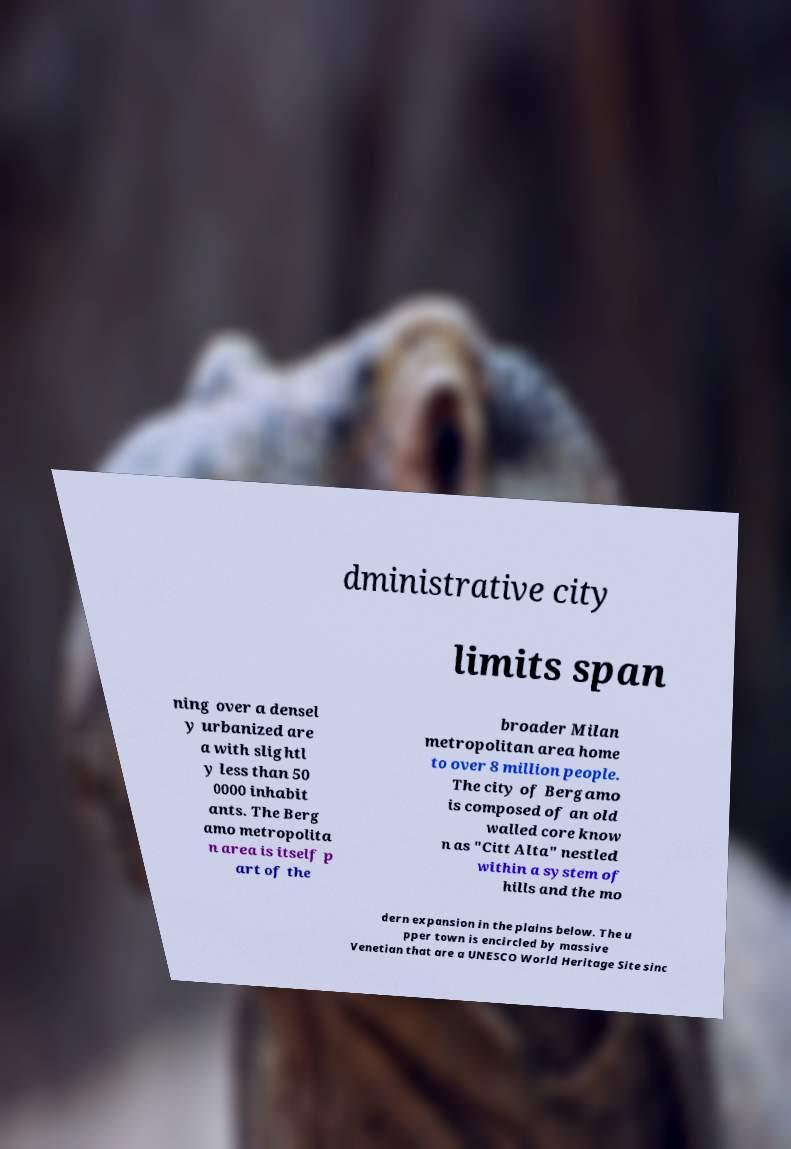I need the written content from this picture converted into text. Can you do that? dministrative city limits span ning over a densel y urbanized are a with slightl y less than 50 0000 inhabit ants. The Berg amo metropolita n area is itself p art of the broader Milan metropolitan area home to over 8 million people. The city of Bergamo is composed of an old walled core know n as "Citt Alta" nestled within a system of hills and the mo dern expansion in the plains below. The u pper town is encircled by massive Venetian that are a UNESCO World Heritage Site sinc 